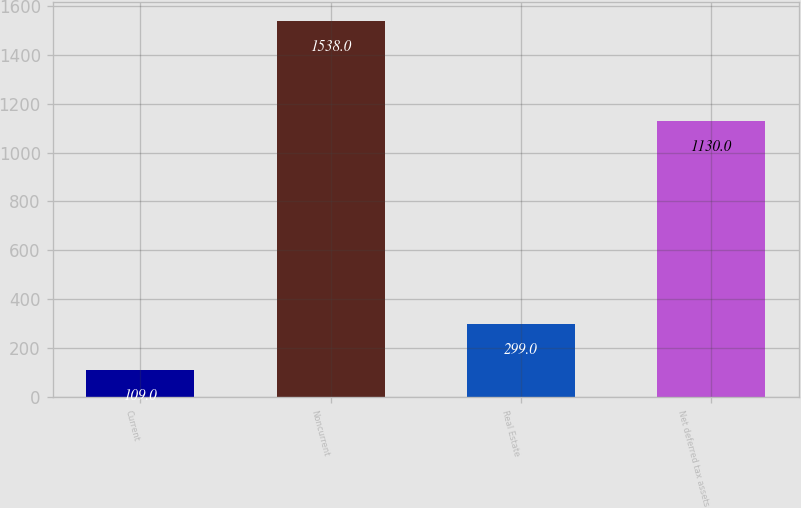Convert chart to OTSL. <chart><loc_0><loc_0><loc_500><loc_500><bar_chart><fcel>Current<fcel>Noncurrent<fcel>Real Estate<fcel>Net deferred tax assets<nl><fcel>109<fcel>1538<fcel>299<fcel>1130<nl></chart> 